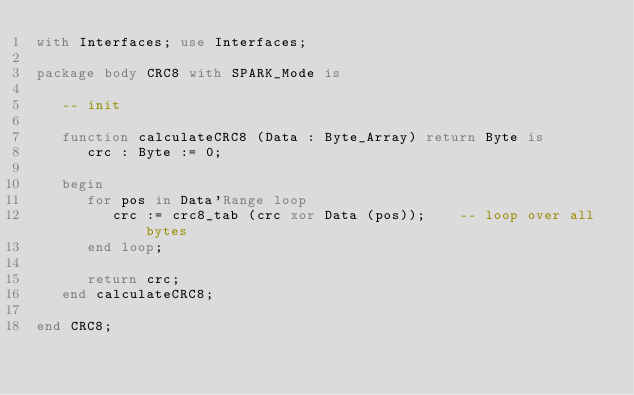Convert code to text. <code><loc_0><loc_0><loc_500><loc_500><_Ada_>with Interfaces; use Interfaces;

package body CRC8 with SPARK_Mode is

   -- init

   function calculateCRC8 (Data : Byte_Array) return Byte is
      crc : Byte := 0;

   begin
      for pos in Data'Range loop
         crc := crc8_tab (crc xor Data (pos));    -- loop over all bytes
      end loop;

      return crc;
   end calculateCRC8;

end CRC8;
</code> 